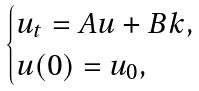<formula> <loc_0><loc_0><loc_500><loc_500>\begin{cases} u _ { t } = A u + B k , \\ u ( 0 ) = u _ { 0 } , \end{cases}</formula> 